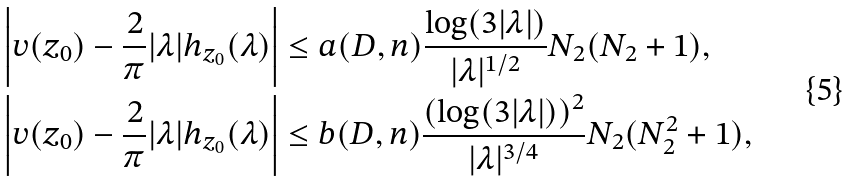<formula> <loc_0><loc_0><loc_500><loc_500>\left | v ( z _ { 0 } ) - \frac { 2 } { \pi } | \lambda | h _ { z _ { 0 } } ( \lambda ) \right | & \leq a ( D , n ) \frac { \log ( 3 | \lambda | ) } { | \lambda | ^ { 1 / 2 } } N _ { 2 } ( N _ { 2 } + 1 ) , \\ \left | v ( z _ { 0 } ) - \frac { 2 } { \pi } | \lambda | h _ { z _ { 0 } } ( \lambda ) \right | & \leq b ( D , n ) \frac { ( \log ( 3 | \lambda | ) ) ^ { 2 } } { | \lambda | ^ { 3 / 4 } } N _ { 2 } ( N _ { 2 } ^ { 2 } + 1 ) ,</formula> 